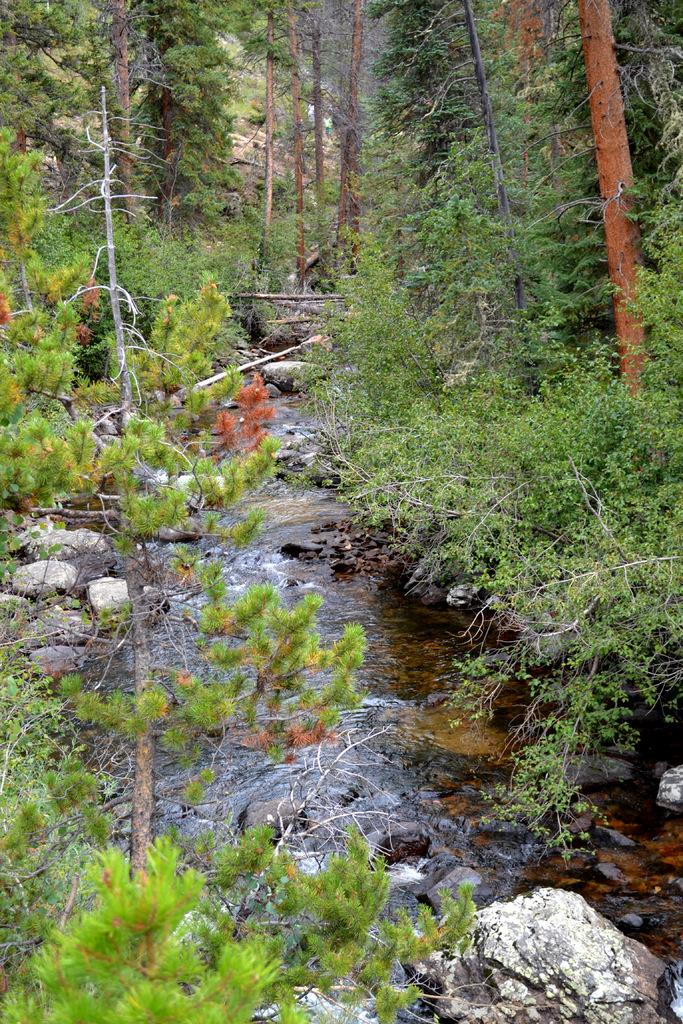What is the primary feature of the image? The primary feature of the image is the water flow. What can be seen in the background of the image? There are many trees visible in the background. What is present at the bottom of the image? There are plants and stones at the bottom of the image. Can you see a kitten playing on the bridge in the image? There is no bridge or kitten present in the image. What type of yard is visible in the image? The image does not show a yard; it features water flow, trees, plants, and stones. 